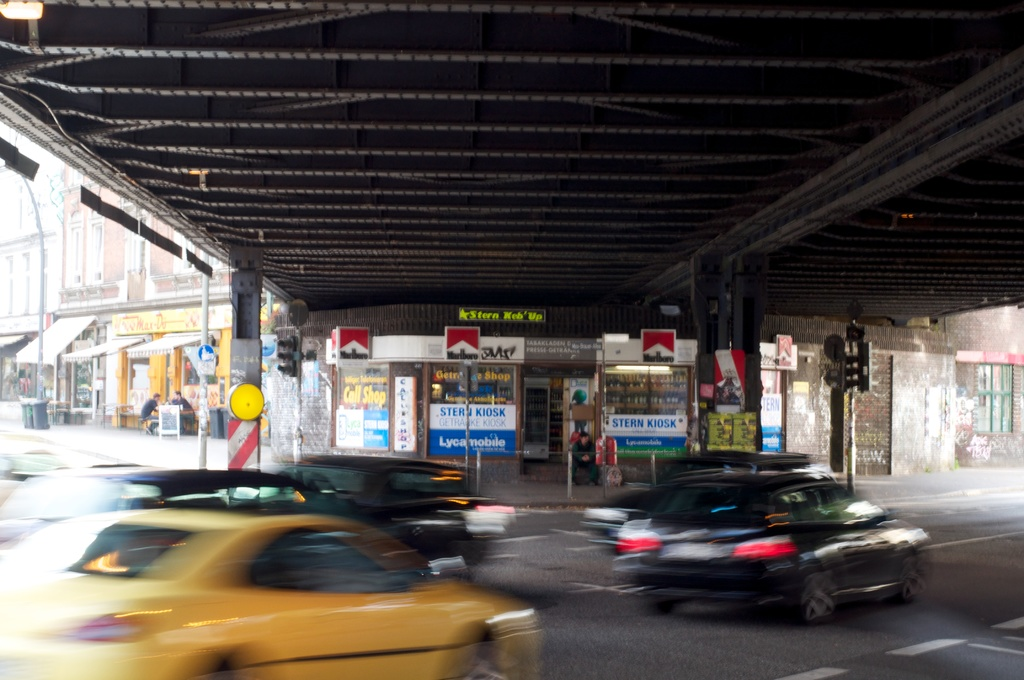Provide a one-sentence caption for the provided image. A busy urban underpass features a variety of small storefronts, including a kiosk and a gift shop, as cars rush by on the road. 